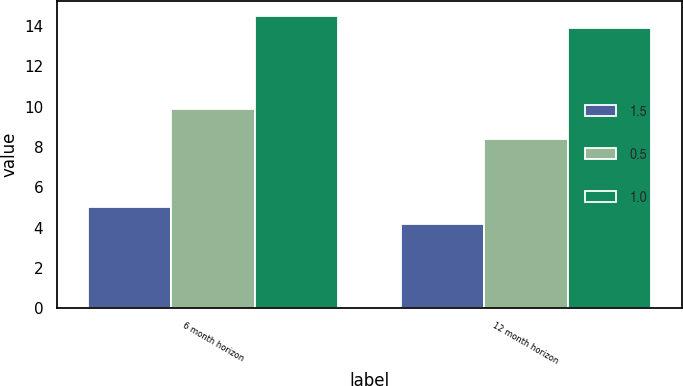<chart> <loc_0><loc_0><loc_500><loc_500><stacked_bar_chart><ecel><fcel>6 month horizon<fcel>12 month horizon<nl><fcel>1.5<fcel>5<fcel>4.2<nl><fcel>0.5<fcel>9.9<fcel>8.4<nl><fcel>1<fcel>14.5<fcel>13.9<nl></chart> 